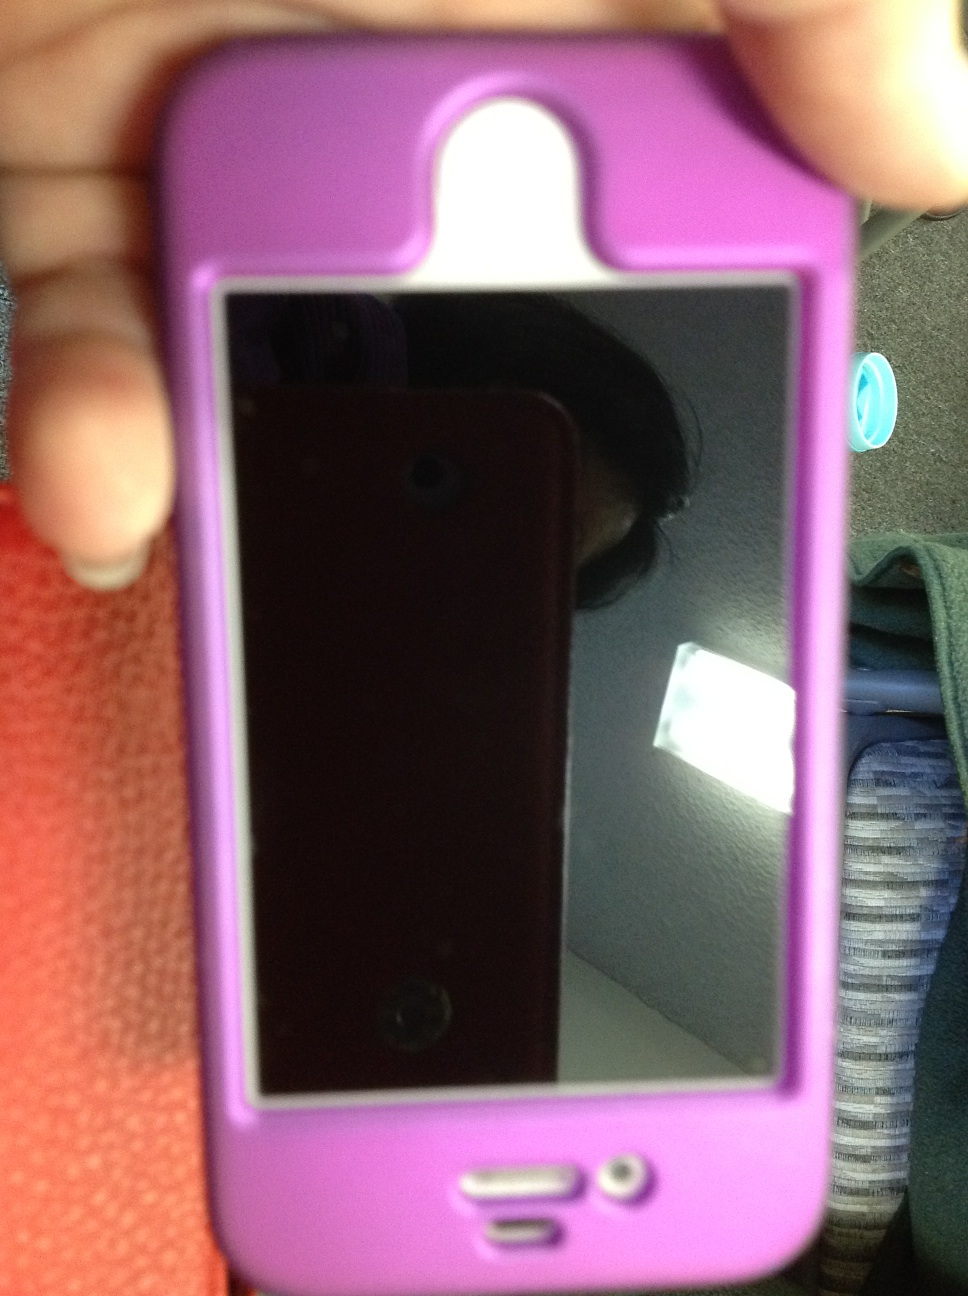What is this? This is an iPhone with a pink protective case. The phone's screen is currently off, and the reflective surface shows the silhouette of the person taking the photo. 